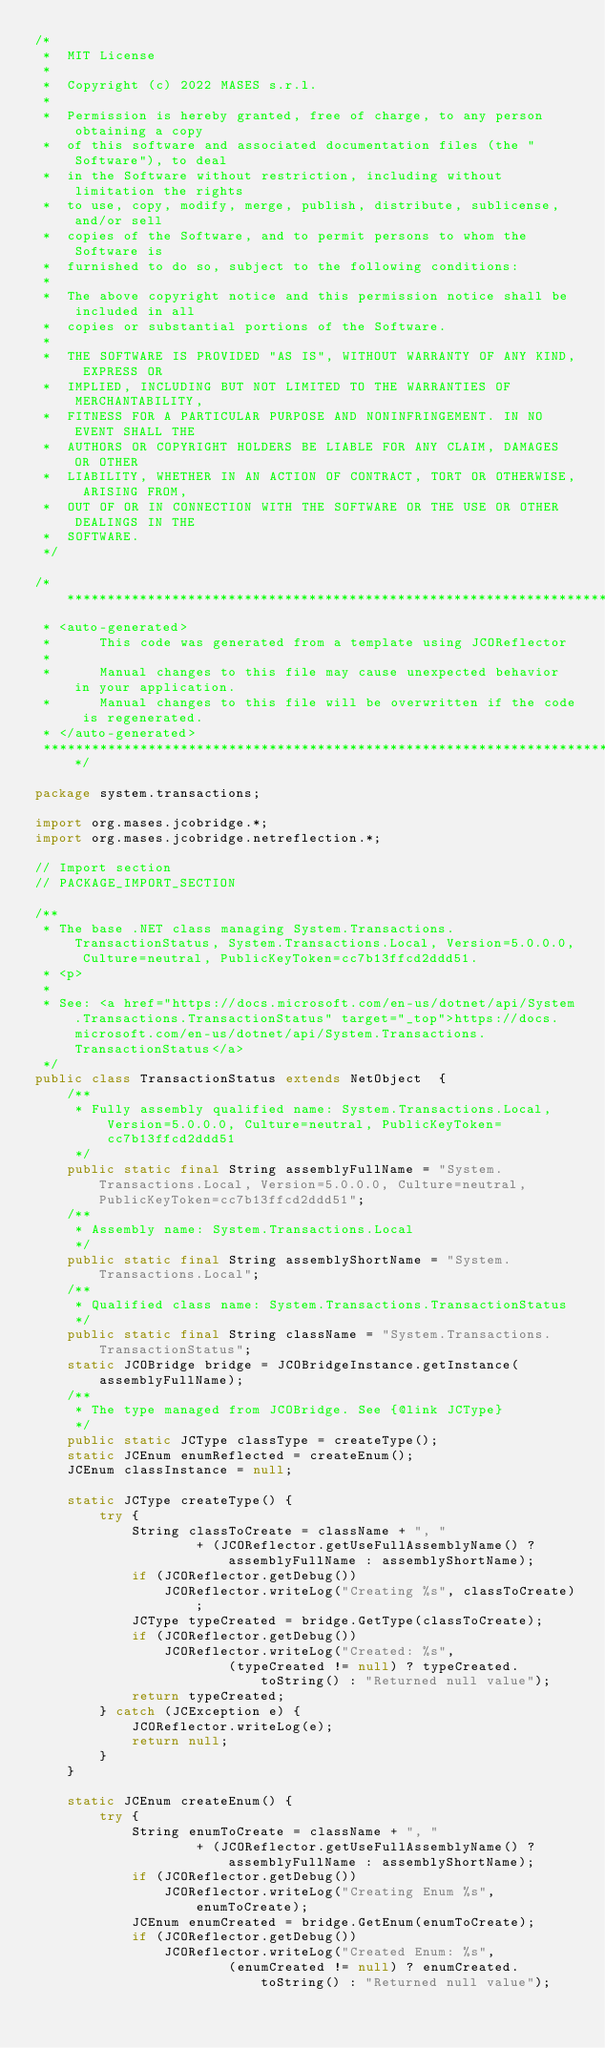<code> <loc_0><loc_0><loc_500><loc_500><_Java_>/*
 *  MIT License
 *
 *  Copyright (c) 2022 MASES s.r.l.
 *
 *  Permission is hereby granted, free of charge, to any person obtaining a copy
 *  of this software and associated documentation files (the "Software"), to deal
 *  in the Software without restriction, including without limitation the rights
 *  to use, copy, modify, merge, publish, distribute, sublicense, and/or sell
 *  copies of the Software, and to permit persons to whom the Software is
 *  furnished to do so, subject to the following conditions:
 *
 *  The above copyright notice and this permission notice shall be included in all
 *  copies or substantial portions of the Software.
 *
 *  THE SOFTWARE IS PROVIDED "AS IS", WITHOUT WARRANTY OF ANY KIND, EXPRESS OR
 *  IMPLIED, INCLUDING BUT NOT LIMITED TO THE WARRANTIES OF MERCHANTABILITY,
 *  FITNESS FOR A PARTICULAR PURPOSE AND NONINFRINGEMENT. IN NO EVENT SHALL THE
 *  AUTHORS OR COPYRIGHT HOLDERS BE LIABLE FOR ANY CLAIM, DAMAGES OR OTHER
 *  LIABILITY, WHETHER IN AN ACTION OF CONTRACT, TORT OR OTHERWISE, ARISING FROM,
 *  OUT OF OR IN CONNECTION WITH THE SOFTWARE OR THE USE OR OTHER DEALINGS IN THE
 *  SOFTWARE.
 */

/**************************************************************************************
 * <auto-generated>
 *      This code was generated from a template using JCOReflector
 * 
 *      Manual changes to this file may cause unexpected behavior in your application.
 *      Manual changes to this file will be overwritten if the code is regenerated.
 * </auto-generated>
 *************************************************************************************/

package system.transactions;

import org.mases.jcobridge.*;
import org.mases.jcobridge.netreflection.*;

// Import section
// PACKAGE_IMPORT_SECTION

/**
 * The base .NET class managing System.Transactions.TransactionStatus, System.Transactions.Local, Version=5.0.0.0, Culture=neutral, PublicKeyToken=cc7b13ffcd2ddd51.
 * <p>
 * 
 * See: <a href="https://docs.microsoft.com/en-us/dotnet/api/System.Transactions.TransactionStatus" target="_top">https://docs.microsoft.com/en-us/dotnet/api/System.Transactions.TransactionStatus</a>
 */
public class TransactionStatus extends NetObject  {
    /**
     * Fully assembly qualified name: System.Transactions.Local, Version=5.0.0.0, Culture=neutral, PublicKeyToken=cc7b13ffcd2ddd51
     */
    public static final String assemblyFullName = "System.Transactions.Local, Version=5.0.0.0, Culture=neutral, PublicKeyToken=cc7b13ffcd2ddd51";
    /**
     * Assembly name: System.Transactions.Local
     */
    public static final String assemblyShortName = "System.Transactions.Local";
    /**
     * Qualified class name: System.Transactions.TransactionStatus
     */
    public static final String className = "System.Transactions.TransactionStatus";
    static JCOBridge bridge = JCOBridgeInstance.getInstance(assemblyFullName);
    /**
     * The type managed from JCOBridge. See {@link JCType}
     */
    public static JCType classType = createType();
    static JCEnum enumReflected = createEnum();
    JCEnum classInstance = null;

    static JCType createType() {
        try {
            String classToCreate = className + ", "
                    + (JCOReflector.getUseFullAssemblyName() ? assemblyFullName : assemblyShortName);
            if (JCOReflector.getDebug())
                JCOReflector.writeLog("Creating %s", classToCreate);
            JCType typeCreated = bridge.GetType(classToCreate);
            if (JCOReflector.getDebug())
                JCOReflector.writeLog("Created: %s",
                        (typeCreated != null) ? typeCreated.toString() : "Returned null value");
            return typeCreated;
        } catch (JCException e) {
            JCOReflector.writeLog(e);
            return null;
        }
    }

    static JCEnum createEnum() {
        try {
            String enumToCreate = className + ", "
                    + (JCOReflector.getUseFullAssemblyName() ? assemblyFullName : assemblyShortName);
            if (JCOReflector.getDebug())
                JCOReflector.writeLog("Creating Enum %s", enumToCreate);
            JCEnum enumCreated = bridge.GetEnum(enumToCreate);
            if (JCOReflector.getDebug())
                JCOReflector.writeLog("Created Enum: %s",
                        (enumCreated != null) ? enumCreated.toString() : "Returned null value");</code> 